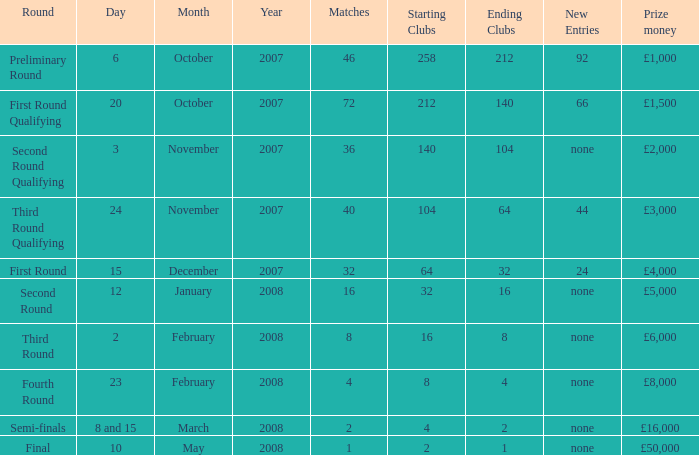What is the typical outcome for competitions with a cash prize of £3,000? 40.0. 